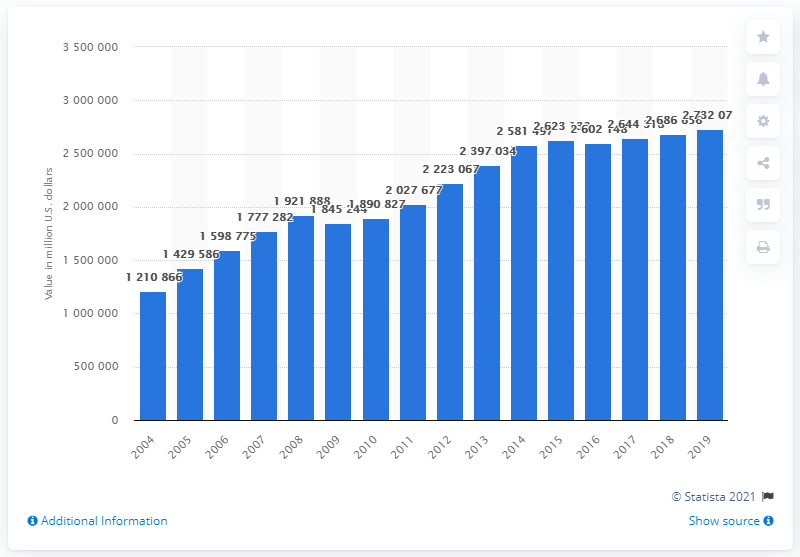List a handful of essential elements in this visual. In 2018, the total value of farmland and buildings in the United States was approximately 268,665,600 dollars. 